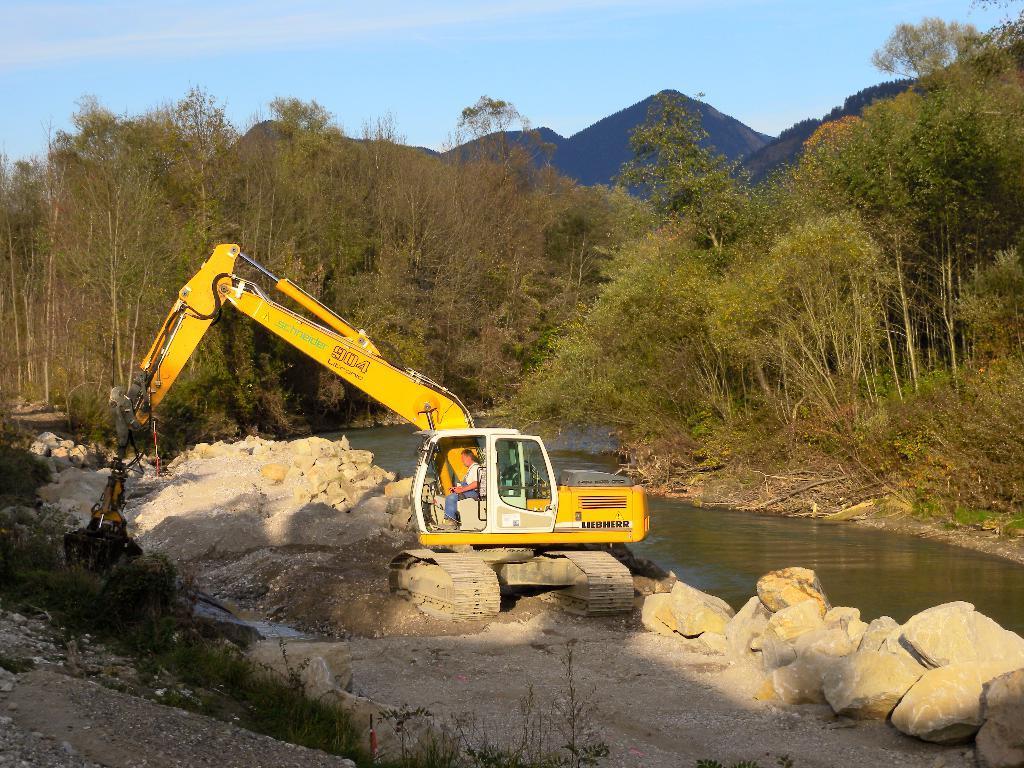Could you give a brief overview of what you see in this image? There is a person inside an excavator. This is water and there are stones. This is grass. In the background we can see trees, mountain, and sky. 